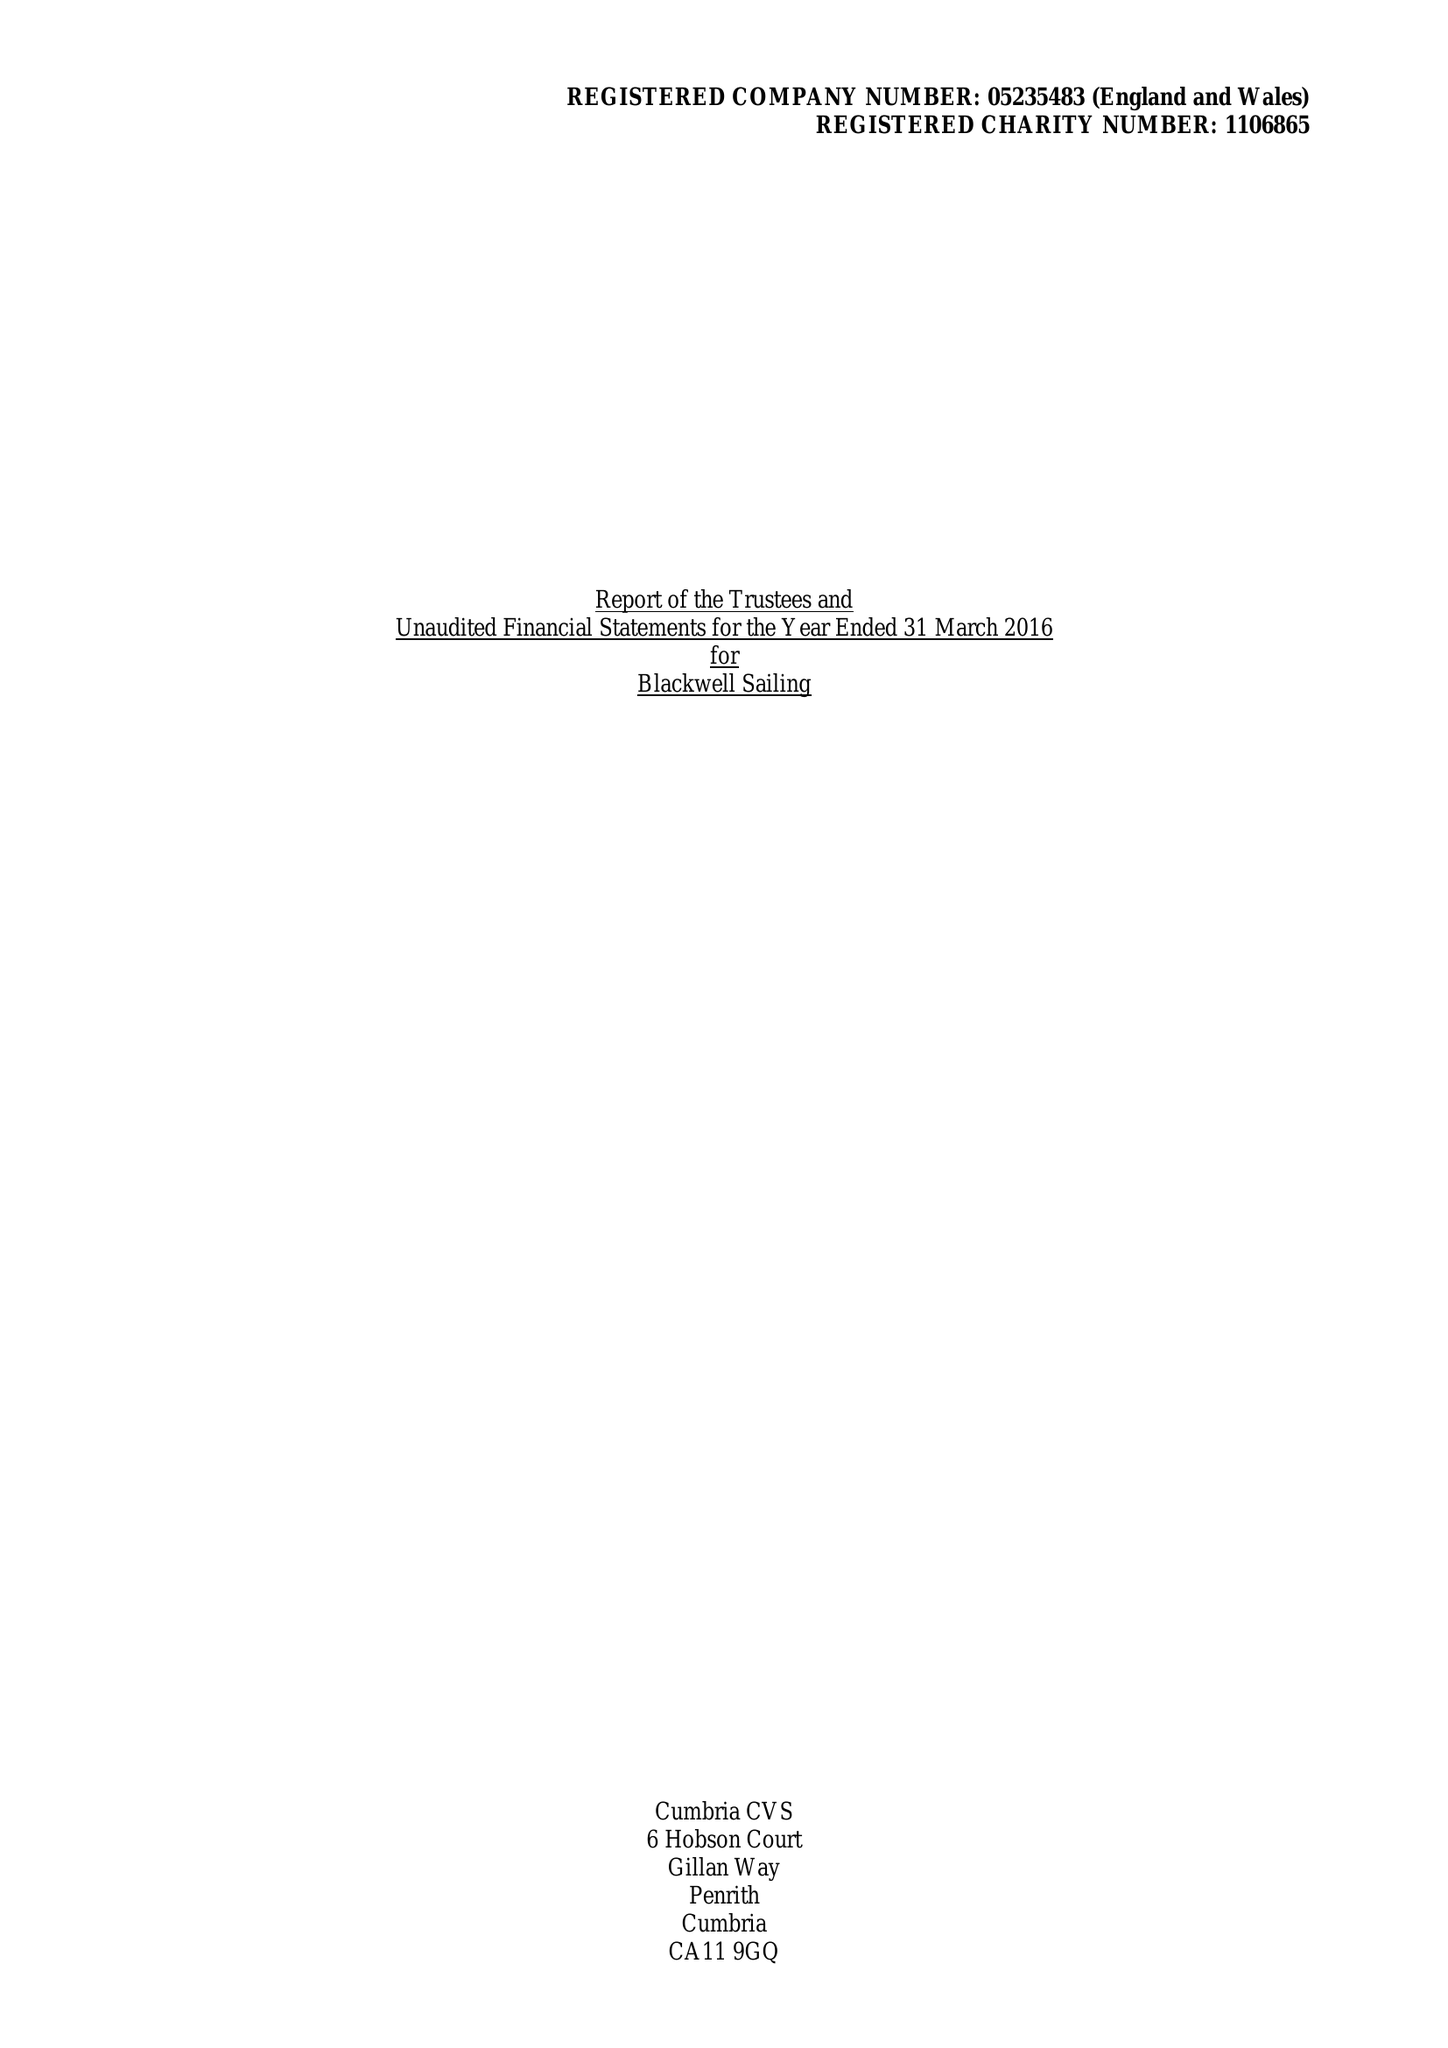What is the value for the address__post_town?
Answer the question using a single word or phrase. WINDERMERE 